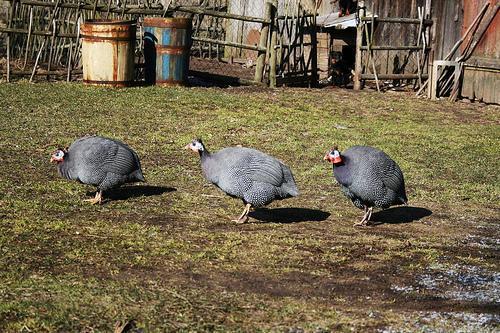How many birds are there?
Give a very brief answer. 3. How many birds can you see?
Give a very brief answer. 3. How many lanes of traffic does a car on the right have to cross in order to turn left?
Give a very brief answer. 0. 